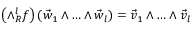<formula> <loc_0><loc_0><loc_500><loc_500>\left ( \land _ { R } ^ { l } f \right ) ( \vec { w } _ { 1 } \land \dots c \land \vec { w } _ { l } ) = \vec { v } _ { 1 } \land \dots c \land \vec { v } _ { l }</formula> 